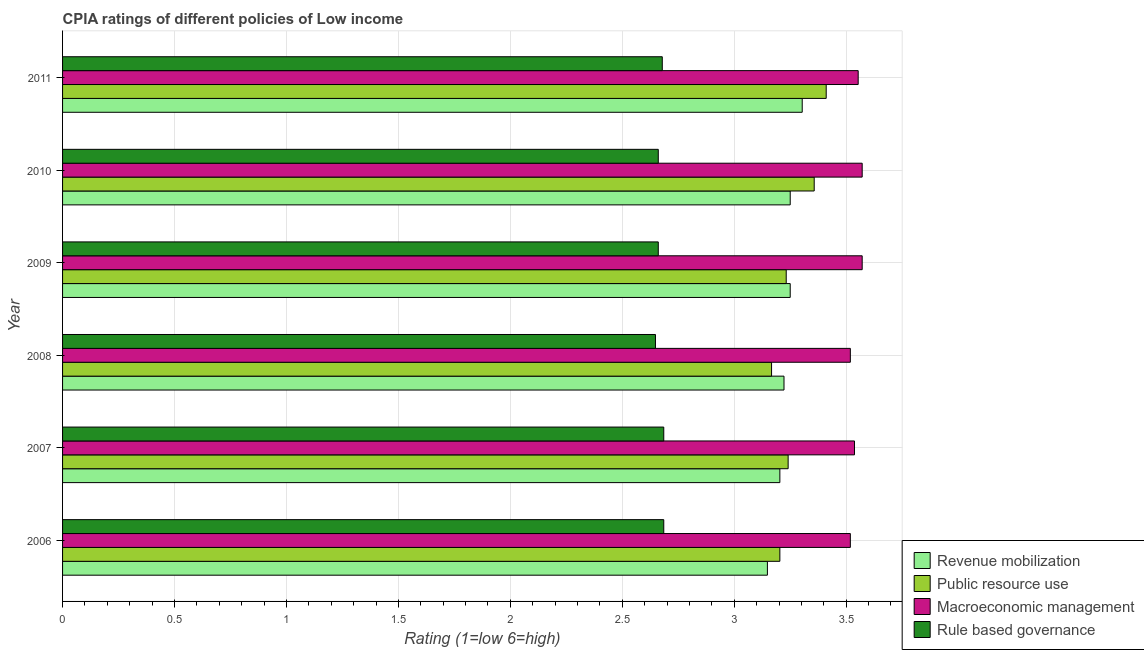How many different coloured bars are there?
Make the answer very short. 4. Are the number of bars on each tick of the Y-axis equal?
Make the answer very short. Yes. How many bars are there on the 4th tick from the bottom?
Your answer should be very brief. 4. In how many cases, is the number of bars for a given year not equal to the number of legend labels?
Keep it short and to the point. 0. Across all years, what is the maximum cpia rating of public resource use?
Make the answer very short. 3.41. Across all years, what is the minimum cpia rating of public resource use?
Ensure brevity in your answer.  3.17. In which year was the cpia rating of rule based governance maximum?
Offer a terse response. 2006. In which year was the cpia rating of revenue mobilization minimum?
Offer a very short reply. 2006. What is the total cpia rating of revenue mobilization in the graph?
Keep it short and to the point. 19.38. What is the difference between the cpia rating of revenue mobilization in 2007 and that in 2009?
Provide a short and direct response. -0.05. What is the average cpia rating of revenue mobilization per year?
Provide a short and direct response. 3.23. In the year 2007, what is the difference between the cpia rating of public resource use and cpia rating of macroeconomic management?
Make the answer very short. -0.3. What is the ratio of the cpia rating of revenue mobilization in 2006 to that in 2007?
Your answer should be compact. 0.98. What is the difference between the highest and the second highest cpia rating of public resource use?
Your answer should be compact. 0.05. In how many years, is the cpia rating of public resource use greater than the average cpia rating of public resource use taken over all years?
Ensure brevity in your answer.  2. Is the sum of the cpia rating of rule based governance in 2010 and 2011 greater than the maximum cpia rating of public resource use across all years?
Give a very brief answer. Yes. What does the 1st bar from the top in 2010 represents?
Offer a terse response. Rule based governance. What does the 3rd bar from the bottom in 2008 represents?
Provide a short and direct response. Macroeconomic management. Does the graph contain any zero values?
Make the answer very short. No. Does the graph contain grids?
Provide a short and direct response. Yes. Where does the legend appear in the graph?
Provide a succinct answer. Bottom right. How many legend labels are there?
Your answer should be very brief. 4. What is the title of the graph?
Your response must be concise. CPIA ratings of different policies of Low income. What is the label or title of the X-axis?
Make the answer very short. Rating (1=low 6=high). What is the label or title of the Y-axis?
Offer a very short reply. Year. What is the Rating (1=low 6=high) in Revenue mobilization in 2006?
Make the answer very short. 3.15. What is the Rating (1=low 6=high) of Public resource use in 2006?
Your answer should be compact. 3.2. What is the Rating (1=low 6=high) of Macroeconomic management in 2006?
Offer a very short reply. 3.52. What is the Rating (1=low 6=high) of Rule based governance in 2006?
Make the answer very short. 2.69. What is the Rating (1=low 6=high) in Revenue mobilization in 2007?
Give a very brief answer. 3.2. What is the Rating (1=low 6=high) of Public resource use in 2007?
Offer a very short reply. 3.24. What is the Rating (1=low 6=high) of Macroeconomic management in 2007?
Provide a short and direct response. 3.54. What is the Rating (1=low 6=high) in Rule based governance in 2007?
Keep it short and to the point. 2.69. What is the Rating (1=low 6=high) in Revenue mobilization in 2008?
Offer a very short reply. 3.22. What is the Rating (1=low 6=high) of Public resource use in 2008?
Make the answer very short. 3.17. What is the Rating (1=low 6=high) in Macroeconomic management in 2008?
Your answer should be very brief. 3.52. What is the Rating (1=low 6=high) of Rule based governance in 2008?
Offer a very short reply. 2.65. What is the Rating (1=low 6=high) of Public resource use in 2009?
Make the answer very short. 3.23. What is the Rating (1=low 6=high) of Macroeconomic management in 2009?
Give a very brief answer. 3.57. What is the Rating (1=low 6=high) of Rule based governance in 2009?
Offer a very short reply. 2.66. What is the Rating (1=low 6=high) in Public resource use in 2010?
Offer a terse response. 3.36. What is the Rating (1=low 6=high) in Macroeconomic management in 2010?
Offer a very short reply. 3.57. What is the Rating (1=low 6=high) of Rule based governance in 2010?
Your response must be concise. 2.66. What is the Rating (1=low 6=high) of Revenue mobilization in 2011?
Offer a very short reply. 3.3. What is the Rating (1=low 6=high) of Public resource use in 2011?
Offer a very short reply. 3.41. What is the Rating (1=low 6=high) in Macroeconomic management in 2011?
Provide a short and direct response. 3.55. What is the Rating (1=low 6=high) of Rule based governance in 2011?
Make the answer very short. 2.68. Across all years, what is the maximum Rating (1=low 6=high) in Revenue mobilization?
Keep it short and to the point. 3.3. Across all years, what is the maximum Rating (1=low 6=high) of Public resource use?
Give a very brief answer. 3.41. Across all years, what is the maximum Rating (1=low 6=high) in Macroeconomic management?
Offer a very short reply. 3.57. Across all years, what is the maximum Rating (1=low 6=high) in Rule based governance?
Your response must be concise. 2.69. Across all years, what is the minimum Rating (1=low 6=high) in Revenue mobilization?
Keep it short and to the point. 3.15. Across all years, what is the minimum Rating (1=low 6=high) in Public resource use?
Provide a succinct answer. 3.17. Across all years, what is the minimum Rating (1=low 6=high) in Macroeconomic management?
Offer a very short reply. 3.52. Across all years, what is the minimum Rating (1=low 6=high) of Rule based governance?
Keep it short and to the point. 2.65. What is the total Rating (1=low 6=high) of Revenue mobilization in the graph?
Offer a very short reply. 19.38. What is the total Rating (1=low 6=high) of Public resource use in the graph?
Offer a very short reply. 19.61. What is the total Rating (1=low 6=high) of Macroeconomic management in the graph?
Provide a short and direct response. 21.27. What is the total Rating (1=low 6=high) in Rule based governance in the graph?
Your answer should be very brief. 16.02. What is the difference between the Rating (1=low 6=high) in Revenue mobilization in 2006 and that in 2007?
Your answer should be very brief. -0.06. What is the difference between the Rating (1=low 6=high) in Public resource use in 2006 and that in 2007?
Offer a very short reply. -0.04. What is the difference between the Rating (1=low 6=high) of Macroeconomic management in 2006 and that in 2007?
Keep it short and to the point. -0.02. What is the difference between the Rating (1=low 6=high) of Rule based governance in 2006 and that in 2007?
Keep it short and to the point. 0. What is the difference between the Rating (1=low 6=high) of Revenue mobilization in 2006 and that in 2008?
Provide a short and direct response. -0.07. What is the difference between the Rating (1=low 6=high) of Public resource use in 2006 and that in 2008?
Provide a succinct answer. 0.04. What is the difference between the Rating (1=low 6=high) of Macroeconomic management in 2006 and that in 2008?
Your response must be concise. 0. What is the difference between the Rating (1=low 6=high) of Rule based governance in 2006 and that in 2008?
Your answer should be very brief. 0.04. What is the difference between the Rating (1=low 6=high) in Revenue mobilization in 2006 and that in 2009?
Your response must be concise. -0.1. What is the difference between the Rating (1=low 6=high) in Public resource use in 2006 and that in 2009?
Keep it short and to the point. -0.03. What is the difference between the Rating (1=low 6=high) in Macroeconomic management in 2006 and that in 2009?
Provide a short and direct response. -0.05. What is the difference between the Rating (1=low 6=high) in Rule based governance in 2006 and that in 2009?
Provide a short and direct response. 0.02. What is the difference between the Rating (1=low 6=high) in Revenue mobilization in 2006 and that in 2010?
Provide a short and direct response. -0.1. What is the difference between the Rating (1=low 6=high) in Public resource use in 2006 and that in 2010?
Offer a terse response. -0.15. What is the difference between the Rating (1=low 6=high) of Macroeconomic management in 2006 and that in 2010?
Offer a terse response. -0.05. What is the difference between the Rating (1=low 6=high) in Rule based governance in 2006 and that in 2010?
Your answer should be very brief. 0.02. What is the difference between the Rating (1=low 6=high) in Revenue mobilization in 2006 and that in 2011?
Ensure brevity in your answer.  -0.16. What is the difference between the Rating (1=low 6=high) of Public resource use in 2006 and that in 2011?
Make the answer very short. -0.21. What is the difference between the Rating (1=low 6=high) of Macroeconomic management in 2006 and that in 2011?
Offer a very short reply. -0.04. What is the difference between the Rating (1=low 6=high) in Rule based governance in 2006 and that in 2011?
Give a very brief answer. 0.01. What is the difference between the Rating (1=low 6=high) in Revenue mobilization in 2007 and that in 2008?
Provide a succinct answer. -0.02. What is the difference between the Rating (1=low 6=high) in Public resource use in 2007 and that in 2008?
Keep it short and to the point. 0.07. What is the difference between the Rating (1=low 6=high) of Macroeconomic management in 2007 and that in 2008?
Offer a terse response. 0.02. What is the difference between the Rating (1=low 6=high) of Rule based governance in 2007 and that in 2008?
Provide a short and direct response. 0.04. What is the difference between the Rating (1=low 6=high) of Revenue mobilization in 2007 and that in 2009?
Give a very brief answer. -0.05. What is the difference between the Rating (1=low 6=high) in Public resource use in 2007 and that in 2009?
Offer a terse response. 0.01. What is the difference between the Rating (1=low 6=high) of Macroeconomic management in 2007 and that in 2009?
Your answer should be very brief. -0.03. What is the difference between the Rating (1=low 6=high) of Rule based governance in 2007 and that in 2009?
Give a very brief answer. 0.02. What is the difference between the Rating (1=low 6=high) in Revenue mobilization in 2007 and that in 2010?
Provide a short and direct response. -0.05. What is the difference between the Rating (1=low 6=high) in Public resource use in 2007 and that in 2010?
Keep it short and to the point. -0.12. What is the difference between the Rating (1=low 6=high) in Macroeconomic management in 2007 and that in 2010?
Offer a terse response. -0.03. What is the difference between the Rating (1=low 6=high) in Rule based governance in 2007 and that in 2010?
Provide a succinct answer. 0.02. What is the difference between the Rating (1=low 6=high) of Revenue mobilization in 2007 and that in 2011?
Give a very brief answer. -0.1. What is the difference between the Rating (1=low 6=high) in Public resource use in 2007 and that in 2011?
Your response must be concise. -0.17. What is the difference between the Rating (1=low 6=high) of Macroeconomic management in 2007 and that in 2011?
Give a very brief answer. -0.02. What is the difference between the Rating (1=low 6=high) in Rule based governance in 2007 and that in 2011?
Give a very brief answer. 0.01. What is the difference between the Rating (1=low 6=high) in Revenue mobilization in 2008 and that in 2009?
Provide a short and direct response. -0.03. What is the difference between the Rating (1=low 6=high) in Public resource use in 2008 and that in 2009?
Ensure brevity in your answer.  -0.07. What is the difference between the Rating (1=low 6=high) in Macroeconomic management in 2008 and that in 2009?
Make the answer very short. -0.05. What is the difference between the Rating (1=low 6=high) in Rule based governance in 2008 and that in 2009?
Your answer should be compact. -0.01. What is the difference between the Rating (1=low 6=high) in Revenue mobilization in 2008 and that in 2010?
Your answer should be compact. -0.03. What is the difference between the Rating (1=low 6=high) of Public resource use in 2008 and that in 2010?
Your answer should be compact. -0.19. What is the difference between the Rating (1=low 6=high) in Macroeconomic management in 2008 and that in 2010?
Give a very brief answer. -0.05. What is the difference between the Rating (1=low 6=high) in Rule based governance in 2008 and that in 2010?
Give a very brief answer. -0.01. What is the difference between the Rating (1=low 6=high) in Revenue mobilization in 2008 and that in 2011?
Provide a succinct answer. -0.08. What is the difference between the Rating (1=low 6=high) in Public resource use in 2008 and that in 2011?
Provide a short and direct response. -0.24. What is the difference between the Rating (1=low 6=high) in Macroeconomic management in 2008 and that in 2011?
Make the answer very short. -0.04. What is the difference between the Rating (1=low 6=high) of Rule based governance in 2008 and that in 2011?
Provide a succinct answer. -0.03. What is the difference between the Rating (1=low 6=high) in Revenue mobilization in 2009 and that in 2010?
Your answer should be very brief. 0. What is the difference between the Rating (1=low 6=high) in Public resource use in 2009 and that in 2010?
Offer a very short reply. -0.12. What is the difference between the Rating (1=low 6=high) in Rule based governance in 2009 and that in 2010?
Make the answer very short. 0. What is the difference between the Rating (1=low 6=high) of Revenue mobilization in 2009 and that in 2011?
Provide a short and direct response. -0.05. What is the difference between the Rating (1=low 6=high) of Public resource use in 2009 and that in 2011?
Your answer should be compact. -0.18. What is the difference between the Rating (1=low 6=high) of Macroeconomic management in 2009 and that in 2011?
Offer a very short reply. 0.02. What is the difference between the Rating (1=low 6=high) in Rule based governance in 2009 and that in 2011?
Ensure brevity in your answer.  -0.02. What is the difference between the Rating (1=low 6=high) of Revenue mobilization in 2010 and that in 2011?
Ensure brevity in your answer.  -0.05. What is the difference between the Rating (1=low 6=high) of Public resource use in 2010 and that in 2011?
Offer a terse response. -0.05. What is the difference between the Rating (1=low 6=high) of Macroeconomic management in 2010 and that in 2011?
Your response must be concise. 0.02. What is the difference between the Rating (1=low 6=high) of Rule based governance in 2010 and that in 2011?
Provide a short and direct response. -0.02. What is the difference between the Rating (1=low 6=high) of Revenue mobilization in 2006 and the Rating (1=low 6=high) of Public resource use in 2007?
Ensure brevity in your answer.  -0.09. What is the difference between the Rating (1=low 6=high) of Revenue mobilization in 2006 and the Rating (1=low 6=high) of Macroeconomic management in 2007?
Provide a succinct answer. -0.39. What is the difference between the Rating (1=low 6=high) of Revenue mobilization in 2006 and the Rating (1=low 6=high) of Rule based governance in 2007?
Provide a short and direct response. 0.46. What is the difference between the Rating (1=low 6=high) of Public resource use in 2006 and the Rating (1=low 6=high) of Rule based governance in 2007?
Offer a very short reply. 0.52. What is the difference between the Rating (1=low 6=high) in Macroeconomic management in 2006 and the Rating (1=low 6=high) in Rule based governance in 2007?
Offer a very short reply. 0.83. What is the difference between the Rating (1=low 6=high) in Revenue mobilization in 2006 and the Rating (1=low 6=high) in Public resource use in 2008?
Make the answer very short. -0.02. What is the difference between the Rating (1=low 6=high) of Revenue mobilization in 2006 and the Rating (1=low 6=high) of Macroeconomic management in 2008?
Provide a short and direct response. -0.37. What is the difference between the Rating (1=low 6=high) of Public resource use in 2006 and the Rating (1=low 6=high) of Macroeconomic management in 2008?
Ensure brevity in your answer.  -0.31. What is the difference between the Rating (1=low 6=high) of Public resource use in 2006 and the Rating (1=low 6=high) of Rule based governance in 2008?
Ensure brevity in your answer.  0.56. What is the difference between the Rating (1=low 6=high) of Macroeconomic management in 2006 and the Rating (1=low 6=high) of Rule based governance in 2008?
Give a very brief answer. 0.87. What is the difference between the Rating (1=low 6=high) in Revenue mobilization in 2006 and the Rating (1=low 6=high) in Public resource use in 2009?
Make the answer very short. -0.08. What is the difference between the Rating (1=low 6=high) in Revenue mobilization in 2006 and the Rating (1=low 6=high) in Macroeconomic management in 2009?
Provide a short and direct response. -0.42. What is the difference between the Rating (1=low 6=high) of Revenue mobilization in 2006 and the Rating (1=low 6=high) of Rule based governance in 2009?
Provide a succinct answer. 0.49. What is the difference between the Rating (1=low 6=high) in Public resource use in 2006 and the Rating (1=low 6=high) in Macroeconomic management in 2009?
Ensure brevity in your answer.  -0.37. What is the difference between the Rating (1=low 6=high) in Public resource use in 2006 and the Rating (1=low 6=high) in Rule based governance in 2009?
Keep it short and to the point. 0.54. What is the difference between the Rating (1=low 6=high) of Macroeconomic management in 2006 and the Rating (1=low 6=high) of Rule based governance in 2009?
Offer a very short reply. 0.86. What is the difference between the Rating (1=low 6=high) of Revenue mobilization in 2006 and the Rating (1=low 6=high) of Public resource use in 2010?
Provide a succinct answer. -0.21. What is the difference between the Rating (1=low 6=high) in Revenue mobilization in 2006 and the Rating (1=low 6=high) in Macroeconomic management in 2010?
Ensure brevity in your answer.  -0.42. What is the difference between the Rating (1=low 6=high) of Revenue mobilization in 2006 and the Rating (1=low 6=high) of Rule based governance in 2010?
Provide a succinct answer. 0.49. What is the difference between the Rating (1=low 6=high) in Public resource use in 2006 and the Rating (1=low 6=high) in Macroeconomic management in 2010?
Give a very brief answer. -0.37. What is the difference between the Rating (1=low 6=high) in Public resource use in 2006 and the Rating (1=low 6=high) in Rule based governance in 2010?
Offer a terse response. 0.54. What is the difference between the Rating (1=low 6=high) in Macroeconomic management in 2006 and the Rating (1=low 6=high) in Rule based governance in 2010?
Offer a terse response. 0.86. What is the difference between the Rating (1=low 6=high) in Revenue mobilization in 2006 and the Rating (1=low 6=high) in Public resource use in 2011?
Offer a terse response. -0.26. What is the difference between the Rating (1=low 6=high) of Revenue mobilization in 2006 and the Rating (1=low 6=high) of Macroeconomic management in 2011?
Your response must be concise. -0.41. What is the difference between the Rating (1=low 6=high) of Revenue mobilization in 2006 and the Rating (1=low 6=high) of Rule based governance in 2011?
Offer a terse response. 0.47. What is the difference between the Rating (1=low 6=high) of Public resource use in 2006 and the Rating (1=low 6=high) of Macroeconomic management in 2011?
Provide a short and direct response. -0.35. What is the difference between the Rating (1=low 6=high) of Public resource use in 2006 and the Rating (1=low 6=high) of Rule based governance in 2011?
Provide a short and direct response. 0.53. What is the difference between the Rating (1=low 6=high) in Macroeconomic management in 2006 and the Rating (1=low 6=high) in Rule based governance in 2011?
Keep it short and to the point. 0.84. What is the difference between the Rating (1=low 6=high) in Revenue mobilization in 2007 and the Rating (1=low 6=high) in Public resource use in 2008?
Make the answer very short. 0.04. What is the difference between the Rating (1=low 6=high) of Revenue mobilization in 2007 and the Rating (1=low 6=high) of Macroeconomic management in 2008?
Your response must be concise. -0.31. What is the difference between the Rating (1=low 6=high) of Revenue mobilization in 2007 and the Rating (1=low 6=high) of Rule based governance in 2008?
Provide a short and direct response. 0.56. What is the difference between the Rating (1=low 6=high) in Public resource use in 2007 and the Rating (1=low 6=high) in Macroeconomic management in 2008?
Offer a very short reply. -0.28. What is the difference between the Rating (1=low 6=high) in Public resource use in 2007 and the Rating (1=low 6=high) in Rule based governance in 2008?
Offer a terse response. 0.59. What is the difference between the Rating (1=low 6=high) in Revenue mobilization in 2007 and the Rating (1=low 6=high) in Public resource use in 2009?
Your answer should be very brief. -0.03. What is the difference between the Rating (1=low 6=high) in Revenue mobilization in 2007 and the Rating (1=low 6=high) in Macroeconomic management in 2009?
Give a very brief answer. -0.37. What is the difference between the Rating (1=low 6=high) in Revenue mobilization in 2007 and the Rating (1=low 6=high) in Rule based governance in 2009?
Your answer should be very brief. 0.54. What is the difference between the Rating (1=low 6=high) of Public resource use in 2007 and the Rating (1=low 6=high) of Macroeconomic management in 2009?
Offer a terse response. -0.33. What is the difference between the Rating (1=low 6=high) of Public resource use in 2007 and the Rating (1=low 6=high) of Rule based governance in 2009?
Give a very brief answer. 0.58. What is the difference between the Rating (1=low 6=high) in Macroeconomic management in 2007 and the Rating (1=low 6=high) in Rule based governance in 2009?
Provide a succinct answer. 0.88. What is the difference between the Rating (1=low 6=high) of Revenue mobilization in 2007 and the Rating (1=low 6=high) of Public resource use in 2010?
Offer a terse response. -0.15. What is the difference between the Rating (1=low 6=high) of Revenue mobilization in 2007 and the Rating (1=low 6=high) of Macroeconomic management in 2010?
Ensure brevity in your answer.  -0.37. What is the difference between the Rating (1=low 6=high) of Revenue mobilization in 2007 and the Rating (1=low 6=high) of Rule based governance in 2010?
Your answer should be compact. 0.54. What is the difference between the Rating (1=low 6=high) in Public resource use in 2007 and the Rating (1=low 6=high) in Macroeconomic management in 2010?
Give a very brief answer. -0.33. What is the difference between the Rating (1=low 6=high) of Public resource use in 2007 and the Rating (1=low 6=high) of Rule based governance in 2010?
Your response must be concise. 0.58. What is the difference between the Rating (1=low 6=high) of Macroeconomic management in 2007 and the Rating (1=low 6=high) of Rule based governance in 2010?
Offer a terse response. 0.88. What is the difference between the Rating (1=low 6=high) in Revenue mobilization in 2007 and the Rating (1=low 6=high) in Public resource use in 2011?
Your answer should be compact. -0.21. What is the difference between the Rating (1=low 6=high) in Revenue mobilization in 2007 and the Rating (1=low 6=high) in Macroeconomic management in 2011?
Your answer should be very brief. -0.35. What is the difference between the Rating (1=low 6=high) of Revenue mobilization in 2007 and the Rating (1=low 6=high) of Rule based governance in 2011?
Provide a short and direct response. 0.53. What is the difference between the Rating (1=low 6=high) in Public resource use in 2007 and the Rating (1=low 6=high) in Macroeconomic management in 2011?
Provide a short and direct response. -0.31. What is the difference between the Rating (1=low 6=high) of Public resource use in 2007 and the Rating (1=low 6=high) of Rule based governance in 2011?
Make the answer very short. 0.56. What is the difference between the Rating (1=low 6=high) in Macroeconomic management in 2007 and the Rating (1=low 6=high) in Rule based governance in 2011?
Keep it short and to the point. 0.86. What is the difference between the Rating (1=low 6=high) of Revenue mobilization in 2008 and the Rating (1=low 6=high) of Public resource use in 2009?
Keep it short and to the point. -0.01. What is the difference between the Rating (1=low 6=high) of Revenue mobilization in 2008 and the Rating (1=low 6=high) of Macroeconomic management in 2009?
Offer a terse response. -0.35. What is the difference between the Rating (1=low 6=high) of Revenue mobilization in 2008 and the Rating (1=low 6=high) of Rule based governance in 2009?
Your answer should be very brief. 0.56. What is the difference between the Rating (1=low 6=high) in Public resource use in 2008 and the Rating (1=low 6=high) in Macroeconomic management in 2009?
Provide a succinct answer. -0.4. What is the difference between the Rating (1=low 6=high) of Public resource use in 2008 and the Rating (1=low 6=high) of Rule based governance in 2009?
Provide a succinct answer. 0.51. What is the difference between the Rating (1=low 6=high) of Macroeconomic management in 2008 and the Rating (1=low 6=high) of Rule based governance in 2009?
Provide a succinct answer. 0.86. What is the difference between the Rating (1=low 6=high) of Revenue mobilization in 2008 and the Rating (1=low 6=high) of Public resource use in 2010?
Your answer should be compact. -0.13. What is the difference between the Rating (1=low 6=high) in Revenue mobilization in 2008 and the Rating (1=low 6=high) in Macroeconomic management in 2010?
Your answer should be very brief. -0.35. What is the difference between the Rating (1=low 6=high) of Revenue mobilization in 2008 and the Rating (1=low 6=high) of Rule based governance in 2010?
Provide a short and direct response. 0.56. What is the difference between the Rating (1=low 6=high) in Public resource use in 2008 and the Rating (1=low 6=high) in Macroeconomic management in 2010?
Give a very brief answer. -0.4. What is the difference between the Rating (1=low 6=high) in Public resource use in 2008 and the Rating (1=low 6=high) in Rule based governance in 2010?
Your answer should be very brief. 0.51. What is the difference between the Rating (1=low 6=high) in Macroeconomic management in 2008 and the Rating (1=low 6=high) in Rule based governance in 2010?
Give a very brief answer. 0.86. What is the difference between the Rating (1=low 6=high) of Revenue mobilization in 2008 and the Rating (1=low 6=high) of Public resource use in 2011?
Your response must be concise. -0.19. What is the difference between the Rating (1=low 6=high) in Revenue mobilization in 2008 and the Rating (1=low 6=high) in Macroeconomic management in 2011?
Provide a succinct answer. -0.33. What is the difference between the Rating (1=low 6=high) in Revenue mobilization in 2008 and the Rating (1=low 6=high) in Rule based governance in 2011?
Keep it short and to the point. 0.54. What is the difference between the Rating (1=low 6=high) of Public resource use in 2008 and the Rating (1=low 6=high) of Macroeconomic management in 2011?
Provide a short and direct response. -0.39. What is the difference between the Rating (1=low 6=high) of Public resource use in 2008 and the Rating (1=low 6=high) of Rule based governance in 2011?
Provide a succinct answer. 0.49. What is the difference between the Rating (1=low 6=high) of Macroeconomic management in 2008 and the Rating (1=low 6=high) of Rule based governance in 2011?
Offer a terse response. 0.84. What is the difference between the Rating (1=low 6=high) in Revenue mobilization in 2009 and the Rating (1=low 6=high) in Public resource use in 2010?
Provide a short and direct response. -0.11. What is the difference between the Rating (1=low 6=high) in Revenue mobilization in 2009 and the Rating (1=low 6=high) in Macroeconomic management in 2010?
Keep it short and to the point. -0.32. What is the difference between the Rating (1=low 6=high) of Revenue mobilization in 2009 and the Rating (1=low 6=high) of Rule based governance in 2010?
Ensure brevity in your answer.  0.59. What is the difference between the Rating (1=low 6=high) of Public resource use in 2009 and the Rating (1=low 6=high) of Macroeconomic management in 2010?
Make the answer very short. -0.34. What is the difference between the Rating (1=low 6=high) in Public resource use in 2009 and the Rating (1=low 6=high) in Rule based governance in 2010?
Make the answer very short. 0.57. What is the difference between the Rating (1=low 6=high) of Macroeconomic management in 2009 and the Rating (1=low 6=high) of Rule based governance in 2010?
Your response must be concise. 0.91. What is the difference between the Rating (1=low 6=high) in Revenue mobilization in 2009 and the Rating (1=low 6=high) in Public resource use in 2011?
Make the answer very short. -0.16. What is the difference between the Rating (1=low 6=high) of Revenue mobilization in 2009 and the Rating (1=low 6=high) of Macroeconomic management in 2011?
Offer a terse response. -0.3. What is the difference between the Rating (1=low 6=high) of Public resource use in 2009 and the Rating (1=low 6=high) of Macroeconomic management in 2011?
Offer a very short reply. -0.32. What is the difference between the Rating (1=low 6=high) in Public resource use in 2009 and the Rating (1=low 6=high) in Rule based governance in 2011?
Your response must be concise. 0.55. What is the difference between the Rating (1=low 6=high) in Macroeconomic management in 2009 and the Rating (1=low 6=high) in Rule based governance in 2011?
Provide a succinct answer. 0.89. What is the difference between the Rating (1=low 6=high) in Revenue mobilization in 2010 and the Rating (1=low 6=high) in Public resource use in 2011?
Your response must be concise. -0.16. What is the difference between the Rating (1=low 6=high) of Revenue mobilization in 2010 and the Rating (1=low 6=high) of Macroeconomic management in 2011?
Make the answer very short. -0.3. What is the difference between the Rating (1=low 6=high) in Public resource use in 2010 and the Rating (1=low 6=high) in Macroeconomic management in 2011?
Offer a terse response. -0.2. What is the difference between the Rating (1=low 6=high) of Public resource use in 2010 and the Rating (1=low 6=high) of Rule based governance in 2011?
Offer a terse response. 0.68. What is the difference between the Rating (1=low 6=high) in Macroeconomic management in 2010 and the Rating (1=low 6=high) in Rule based governance in 2011?
Offer a terse response. 0.89. What is the average Rating (1=low 6=high) of Revenue mobilization per year?
Provide a succinct answer. 3.23. What is the average Rating (1=low 6=high) in Public resource use per year?
Ensure brevity in your answer.  3.27. What is the average Rating (1=low 6=high) in Macroeconomic management per year?
Provide a succinct answer. 3.55. What is the average Rating (1=low 6=high) of Rule based governance per year?
Make the answer very short. 2.67. In the year 2006, what is the difference between the Rating (1=low 6=high) of Revenue mobilization and Rating (1=low 6=high) of Public resource use?
Keep it short and to the point. -0.06. In the year 2006, what is the difference between the Rating (1=low 6=high) in Revenue mobilization and Rating (1=low 6=high) in Macroeconomic management?
Give a very brief answer. -0.37. In the year 2006, what is the difference between the Rating (1=low 6=high) of Revenue mobilization and Rating (1=low 6=high) of Rule based governance?
Offer a very short reply. 0.46. In the year 2006, what is the difference between the Rating (1=low 6=high) in Public resource use and Rating (1=low 6=high) in Macroeconomic management?
Provide a short and direct response. -0.31. In the year 2006, what is the difference between the Rating (1=low 6=high) of Public resource use and Rating (1=low 6=high) of Rule based governance?
Make the answer very short. 0.52. In the year 2006, what is the difference between the Rating (1=low 6=high) of Macroeconomic management and Rating (1=low 6=high) of Rule based governance?
Your answer should be very brief. 0.83. In the year 2007, what is the difference between the Rating (1=low 6=high) in Revenue mobilization and Rating (1=low 6=high) in Public resource use?
Give a very brief answer. -0.04. In the year 2007, what is the difference between the Rating (1=low 6=high) of Revenue mobilization and Rating (1=low 6=high) of Rule based governance?
Offer a very short reply. 0.52. In the year 2007, what is the difference between the Rating (1=low 6=high) of Public resource use and Rating (1=low 6=high) of Macroeconomic management?
Give a very brief answer. -0.3. In the year 2007, what is the difference between the Rating (1=low 6=high) in Public resource use and Rating (1=low 6=high) in Rule based governance?
Keep it short and to the point. 0.56. In the year 2007, what is the difference between the Rating (1=low 6=high) in Macroeconomic management and Rating (1=low 6=high) in Rule based governance?
Your answer should be very brief. 0.85. In the year 2008, what is the difference between the Rating (1=low 6=high) in Revenue mobilization and Rating (1=low 6=high) in Public resource use?
Your answer should be compact. 0.06. In the year 2008, what is the difference between the Rating (1=low 6=high) of Revenue mobilization and Rating (1=low 6=high) of Macroeconomic management?
Keep it short and to the point. -0.3. In the year 2008, what is the difference between the Rating (1=low 6=high) of Revenue mobilization and Rating (1=low 6=high) of Rule based governance?
Offer a terse response. 0.57. In the year 2008, what is the difference between the Rating (1=low 6=high) in Public resource use and Rating (1=low 6=high) in Macroeconomic management?
Your response must be concise. -0.35. In the year 2008, what is the difference between the Rating (1=low 6=high) of Public resource use and Rating (1=low 6=high) of Rule based governance?
Your answer should be compact. 0.52. In the year 2008, what is the difference between the Rating (1=low 6=high) of Macroeconomic management and Rating (1=low 6=high) of Rule based governance?
Your response must be concise. 0.87. In the year 2009, what is the difference between the Rating (1=low 6=high) of Revenue mobilization and Rating (1=low 6=high) of Public resource use?
Make the answer very short. 0.02. In the year 2009, what is the difference between the Rating (1=low 6=high) of Revenue mobilization and Rating (1=low 6=high) of Macroeconomic management?
Your answer should be compact. -0.32. In the year 2009, what is the difference between the Rating (1=low 6=high) in Revenue mobilization and Rating (1=low 6=high) in Rule based governance?
Your answer should be compact. 0.59. In the year 2009, what is the difference between the Rating (1=low 6=high) of Public resource use and Rating (1=low 6=high) of Macroeconomic management?
Your response must be concise. -0.34. In the year 2009, what is the difference between the Rating (1=low 6=high) in Public resource use and Rating (1=low 6=high) in Rule based governance?
Give a very brief answer. 0.57. In the year 2009, what is the difference between the Rating (1=low 6=high) in Macroeconomic management and Rating (1=low 6=high) in Rule based governance?
Make the answer very short. 0.91. In the year 2010, what is the difference between the Rating (1=low 6=high) in Revenue mobilization and Rating (1=low 6=high) in Public resource use?
Your answer should be very brief. -0.11. In the year 2010, what is the difference between the Rating (1=low 6=high) of Revenue mobilization and Rating (1=low 6=high) of Macroeconomic management?
Your response must be concise. -0.32. In the year 2010, what is the difference between the Rating (1=low 6=high) of Revenue mobilization and Rating (1=low 6=high) of Rule based governance?
Make the answer very short. 0.59. In the year 2010, what is the difference between the Rating (1=low 6=high) in Public resource use and Rating (1=low 6=high) in Macroeconomic management?
Provide a short and direct response. -0.21. In the year 2010, what is the difference between the Rating (1=low 6=high) of Public resource use and Rating (1=low 6=high) of Rule based governance?
Offer a very short reply. 0.7. In the year 2010, what is the difference between the Rating (1=low 6=high) of Macroeconomic management and Rating (1=low 6=high) of Rule based governance?
Ensure brevity in your answer.  0.91. In the year 2011, what is the difference between the Rating (1=low 6=high) in Revenue mobilization and Rating (1=low 6=high) in Public resource use?
Offer a terse response. -0.11. In the year 2011, what is the difference between the Rating (1=low 6=high) in Revenue mobilization and Rating (1=low 6=high) in Macroeconomic management?
Offer a terse response. -0.25. In the year 2011, what is the difference between the Rating (1=low 6=high) in Public resource use and Rating (1=low 6=high) in Macroeconomic management?
Your response must be concise. -0.14. In the year 2011, what is the difference between the Rating (1=low 6=high) of Public resource use and Rating (1=low 6=high) of Rule based governance?
Make the answer very short. 0.73. What is the ratio of the Rating (1=low 6=high) in Revenue mobilization in 2006 to that in 2007?
Make the answer very short. 0.98. What is the ratio of the Rating (1=low 6=high) in Macroeconomic management in 2006 to that in 2007?
Your answer should be very brief. 0.99. What is the ratio of the Rating (1=low 6=high) in Rule based governance in 2006 to that in 2007?
Your response must be concise. 1. What is the ratio of the Rating (1=low 6=high) of Revenue mobilization in 2006 to that in 2008?
Make the answer very short. 0.98. What is the ratio of the Rating (1=low 6=high) in Public resource use in 2006 to that in 2008?
Keep it short and to the point. 1.01. What is the ratio of the Rating (1=low 6=high) in Macroeconomic management in 2006 to that in 2008?
Provide a succinct answer. 1. What is the ratio of the Rating (1=low 6=high) of Rule based governance in 2006 to that in 2008?
Ensure brevity in your answer.  1.01. What is the ratio of the Rating (1=low 6=high) of Revenue mobilization in 2006 to that in 2009?
Make the answer very short. 0.97. What is the ratio of the Rating (1=low 6=high) in Macroeconomic management in 2006 to that in 2009?
Make the answer very short. 0.99. What is the ratio of the Rating (1=low 6=high) of Rule based governance in 2006 to that in 2009?
Your response must be concise. 1.01. What is the ratio of the Rating (1=low 6=high) in Revenue mobilization in 2006 to that in 2010?
Provide a short and direct response. 0.97. What is the ratio of the Rating (1=low 6=high) in Public resource use in 2006 to that in 2010?
Your answer should be compact. 0.95. What is the ratio of the Rating (1=low 6=high) of Macroeconomic management in 2006 to that in 2010?
Offer a very short reply. 0.99. What is the ratio of the Rating (1=low 6=high) of Rule based governance in 2006 to that in 2010?
Offer a terse response. 1.01. What is the ratio of the Rating (1=low 6=high) of Revenue mobilization in 2006 to that in 2011?
Your response must be concise. 0.95. What is the ratio of the Rating (1=low 6=high) in Public resource use in 2006 to that in 2011?
Your answer should be compact. 0.94. What is the ratio of the Rating (1=low 6=high) in Macroeconomic management in 2006 to that in 2011?
Your answer should be compact. 0.99. What is the ratio of the Rating (1=low 6=high) of Public resource use in 2007 to that in 2008?
Give a very brief answer. 1.02. What is the ratio of the Rating (1=low 6=high) in Macroeconomic management in 2007 to that in 2008?
Your answer should be compact. 1.01. What is the ratio of the Rating (1=low 6=high) of Rule based governance in 2007 to that in 2008?
Your response must be concise. 1.01. What is the ratio of the Rating (1=low 6=high) in Revenue mobilization in 2007 to that in 2009?
Offer a very short reply. 0.99. What is the ratio of the Rating (1=low 6=high) in Macroeconomic management in 2007 to that in 2009?
Ensure brevity in your answer.  0.99. What is the ratio of the Rating (1=low 6=high) in Rule based governance in 2007 to that in 2009?
Offer a very short reply. 1.01. What is the ratio of the Rating (1=low 6=high) of Revenue mobilization in 2007 to that in 2010?
Offer a very short reply. 0.99. What is the ratio of the Rating (1=low 6=high) in Public resource use in 2007 to that in 2010?
Give a very brief answer. 0.97. What is the ratio of the Rating (1=low 6=high) of Rule based governance in 2007 to that in 2010?
Ensure brevity in your answer.  1.01. What is the ratio of the Rating (1=low 6=high) of Revenue mobilization in 2007 to that in 2011?
Make the answer very short. 0.97. What is the ratio of the Rating (1=low 6=high) in Public resource use in 2007 to that in 2011?
Your response must be concise. 0.95. What is the ratio of the Rating (1=low 6=high) of Macroeconomic management in 2007 to that in 2011?
Keep it short and to the point. 1. What is the ratio of the Rating (1=low 6=high) in Revenue mobilization in 2008 to that in 2009?
Make the answer very short. 0.99. What is the ratio of the Rating (1=low 6=high) in Public resource use in 2008 to that in 2009?
Your response must be concise. 0.98. What is the ratio of the Rating (1=low 6=high) in Macroeconomic management in 2008 to that in 2009?
Offer a terse response. 0.99. What is the ratio of the Rating (1=low 6=high) in Rule based governance in 2008 to that in 2009?
Make the answer very short. 1. What is the ratio of the Rating (1=low 6=high) in Public resource use in 2008 to that in 2010?
Provide a short and direct response. 0.94. What is the ratio of the Rating (1=low 6=high) in Macroeconomic management in 2008 to that in 2010?
Your response must be concise. 0.99. What is the ratio of the Rating (1=low 6=high) in Rule based governance in 2008 to that in 2010?
Keep it short and to the point. 1. What is the ratio of the Rating (1=low 6=high) in Revenue mobilization in 2008 to that in 2011?
Your answer should be very brief. 0.98. What is the ratio of the Rating (1=low 6=high) of Public resource use in 2008 to that in 2011?
Provide a succinct answer. 0.93. What is the ratio of the Rating (1=low 6=high) in Macroeconomic management in 2008 to that in 2011?
Keep it short and to the point. 0.99. What is the ratio of the Rating (1=low 6=high) of Public resource use in 2009 to that in 2010?
Offer a terse response. 0.96. What is the ratio of the Rating (1=low 6=high) in Rule based governance in 2009 to that in 2010?
Offer a very short reply. 1. What is the ratio of the Rating (1=low 6=high) in Revenue mobilization in 2009 to that in 2011?
Your answer should be very brief. 0.98. What is the ratio of the Rating (1=low 6=high) of Public resource use in 2009 to that in 2011?
Your answer should be very brief. 0.95. What is the ratio of the Rating (1=low 6=high) in Macroeconomic management in 2009 to that in 2011?
Offer a very short reply. 1. What is the ratio of the Rating (1=low 6=high) of Rule based governance in 2009 to that in 2011?
Keep it short and to the point. 0.99. What is the ratio of the Rating (1=low 6=high) of Revenue mobilization in 2010 to that in 2011?
Give a very brief answer. 0.98. What is the ratio of the Rating (1=low 6=high) of Public resource use in 2010 to that in 2011?
Provide a short and direct response. 0.98. What is the ratio of the Rating (1=low 6=high) in Macroeconomic management in 2010 to that in 2011?
Keep it short and to the point. 1. What is the difference between the highest and the second highest Rating (1=low 6=high) of Revenue mobilization?
Offer a terse response. 0.05. What is the difference between the highest and the second highest Rating (1=low 6=high) in Public resource use?
Your response must be concise. 0.05. What is the difference between the highest and the second highest Rating (1=low 6=high) in Rule based governance?
Your answer should be compact. 0. What is the difference between the highest and the lowest Rating (1=low 6=high) of Revenue mobilization?
Your answer should be very brief. 0.16. What is the difference between the highest and the lowest Rating (1=low 6=high) in Public resource use?
Your response must be concise. 0.24. What is the difference between the highest and the lowest Rating (1=low 6=high) in Macroeconomic management?
Offer a terse response. 0.05. What is the difference between the highest and the lowest Rating (1=low 6=high) in Rule based governance?
Your answer should be very brief. 0.04. 